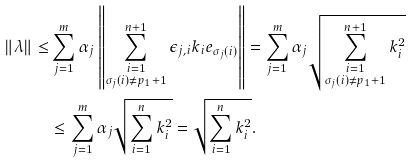Convert formula to latex. <formula><loc_0><loc_0><loc_500><loc_500>\left \| \lambda \right \| \leq & \sum _ { j = 1 } ^ { m } \alpha _ { j } \left \| \sum _ { \substack { i = 1 \\ \sigma _ { j } ( i ) \neq p _ { 1 } + 1 } } ^ { n + 1 } \epsilon _ { j , i } k _ { i } e _ { \sigma _ { j } ( i ) } \right \| = \sum _ { j = 1 } ^ { m } \alpha _ { j } \sqrt { \sum _ { \substack { i = 1 \\ \sigma _ { j } ( i ) \neq p _ { 1 } + 1 } } ^ { n + 1 } k _ { i } ^ { 2 } } \\ & \leq \sum _ { j = 1 } ^ { m } \alpha _ { j } \sqrt { \sum _ { i = 1 } ^ { n } k _ { i } ^ { 2 } } = \sqrt { \sum _ { i = 1 } ^ { n } k _ { i } ^ { 2 } } .</formula> 